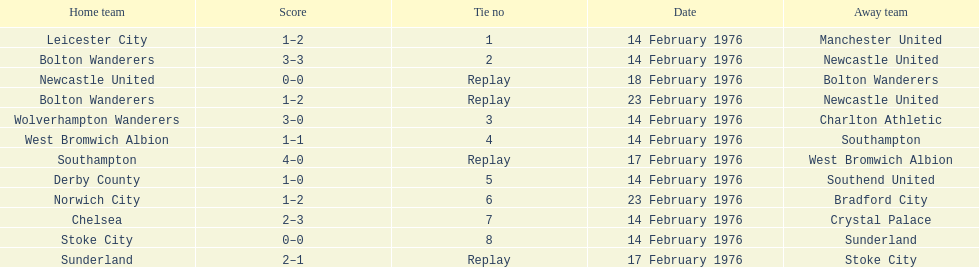How many games did the bolton wanderers and newcastle united play before there was a definitive winner in the fifth round proper? 3. 